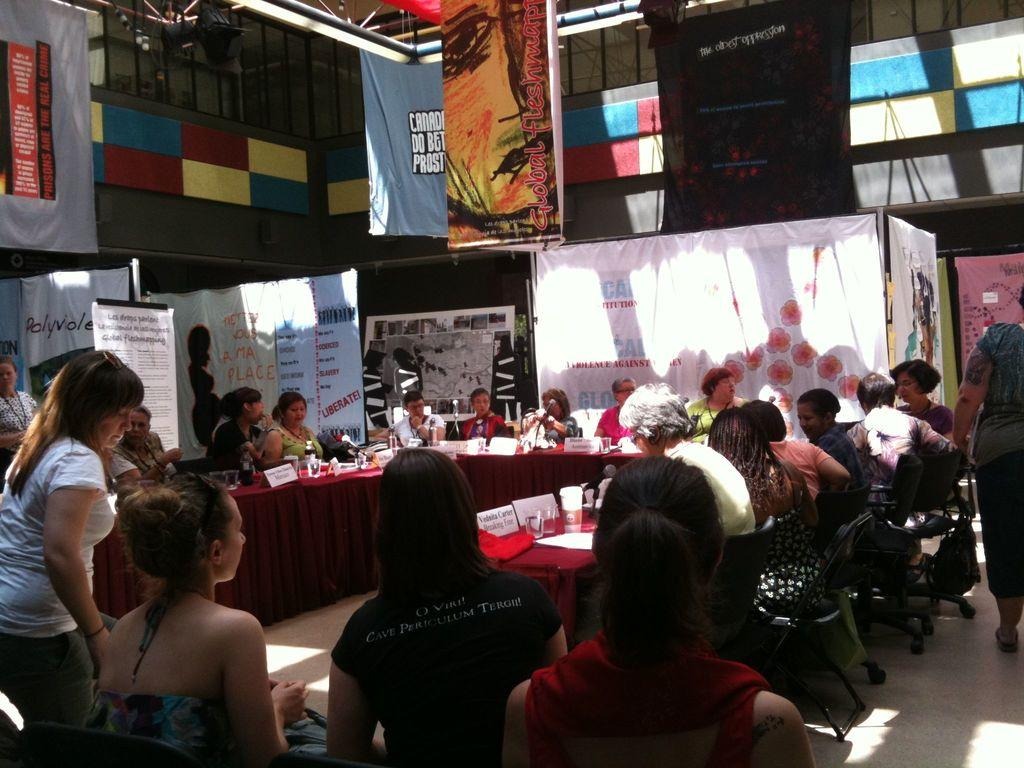What are the people in the image doing? There are people sitting on chairs and standing in the image. What can be seen on the wall behind the people? There are banners in the background of the image. What is present on the table in the image? There are objects on a table in the image. How can the people be identified in the image? There are name boards visible in the image. What is the setting of the image? There is a wall in the background of the image. Can you tell me what type of bird is perched on the name board in the image? There is no bird present on the name board or in the image. What unit does the son of the person standing in the image belong to? There is no information about a son or a specific unit in the image. 